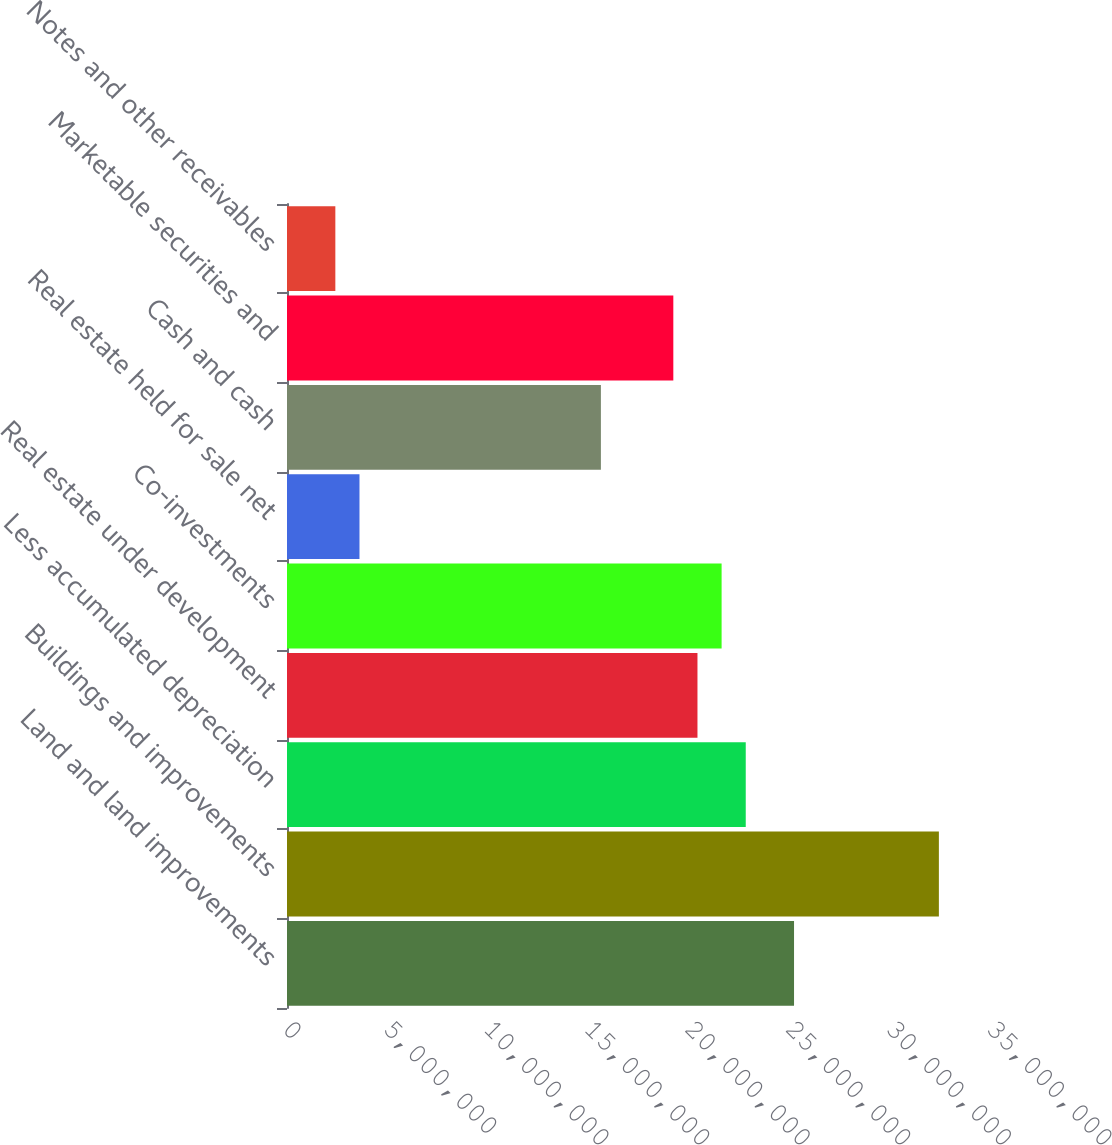Convert chart to OTSL. <chart><loc_0><loc_0><loc_500><loc_500><bar_chart><fcel>Land and land improvements<fcel>Buildings and improvements<fcel>Less accumulated depreciation<fcel>Real estate under development<fcel>Co-investments<fcel>Real estate held for sale net<fcel>Cash and cash<fcel>Marketable securities and<fcel>Notes and other receivables<nl><fcel>2.52075e+07<fcel>3.24089e+07<fcel>2.28071e+07<fcel>2.04067e+07<fcel>2.16069e+07<fcel>3.60353e+06<fcel>1.56058e+07<fcel>1.92064e+07<fcel>2.4033e+06<nl></chart> 